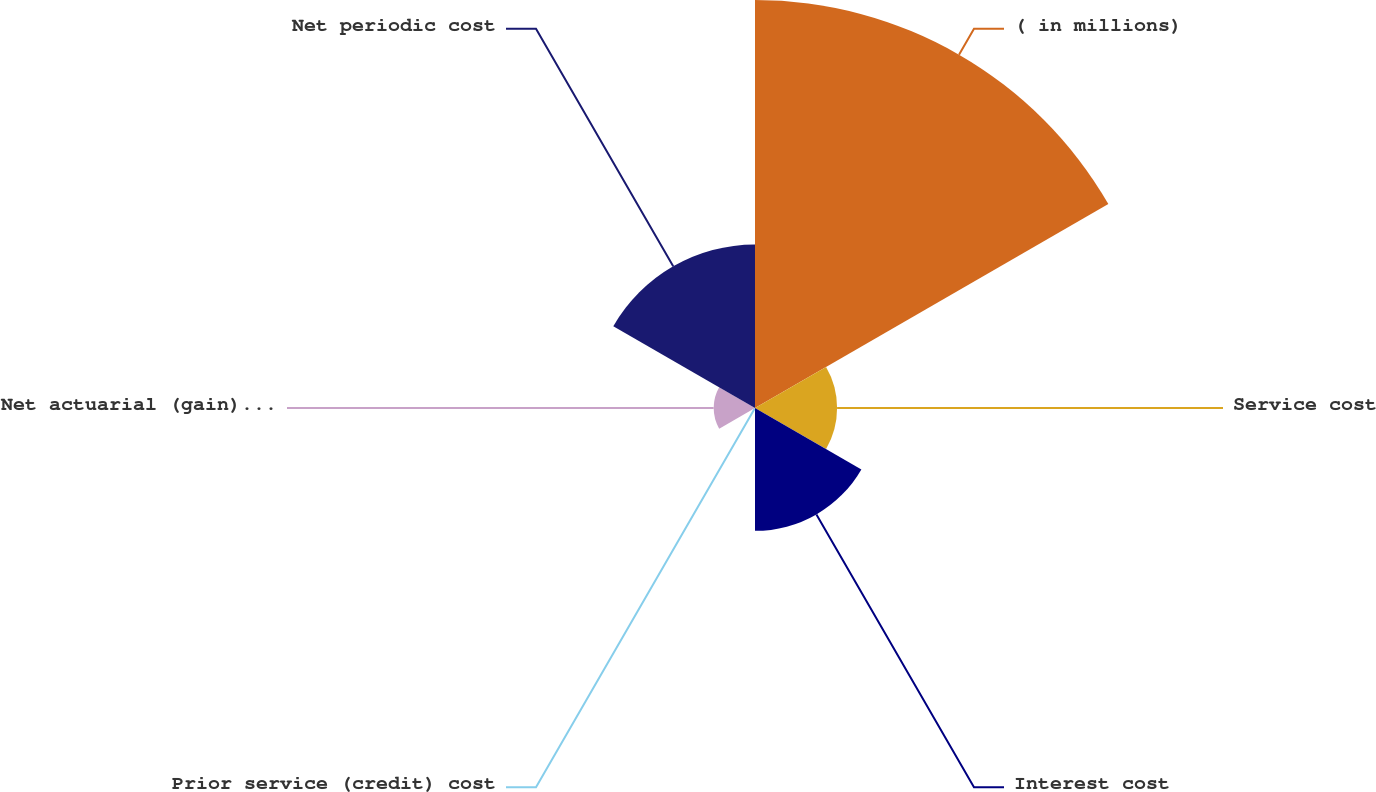Convert chart. <chart><loc_0><loc_0><loc_500><loc_500><pie_chart><fcel>( in millions)<fcel>Service cost<fcel>Interest cost<fcel>Prior service (credit) cost<fcel>Net actuarial (gain) loss<fcel>Net periodic cost<nl><fcel>49.85%<fcel>10.03%<fcel>15.01%<fcel>0.07%<fcel>5.05%<fcel>19.99%<nl></chart> 